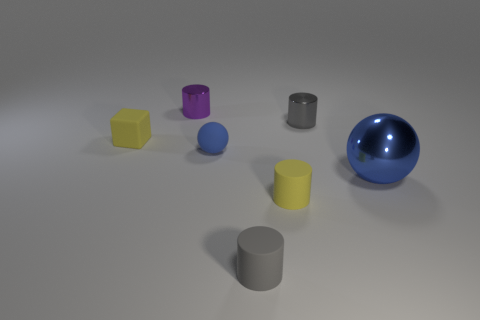Subtract 1 cylinders. How many cylinders are left? 3 Subtract all brown cylinders. Subtract all gray cubes. How many cylinders are left? 4 Add 1 spheres. How many objects exist? 8 Subtract all tiny yellow cylinders. Subtract all blue metallic spheres. How many objects are left? 5 Add 7 purple things. How many purple things are left? 8 Add 6 shiny balls. How many shiny balls exist? 7 Subtract 0 brown balls. How many objects are left? 7 Subtract all spheres. How many objects are left? 5 